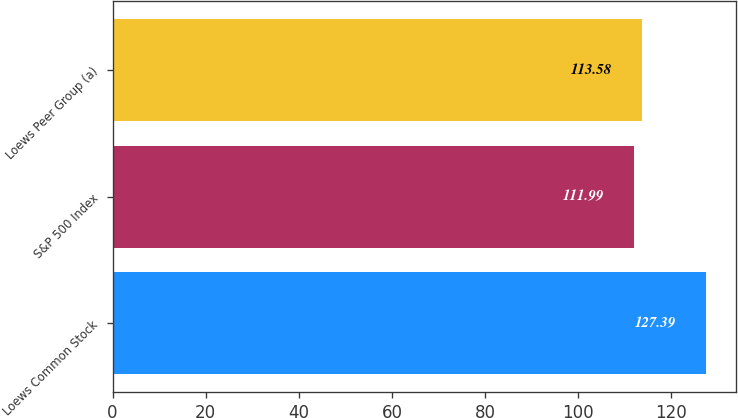Convert chart to OTSL. <chart><loc_0><loc_0><loc_500><loc_500><bar_chart><fcel>Loews Common Stock<fcel>S&P 500 Index<fcel>Loews Peer Group (a)<nl><fcel>127.39<fcel>111.99<fcel>113.58<nl></chart> 